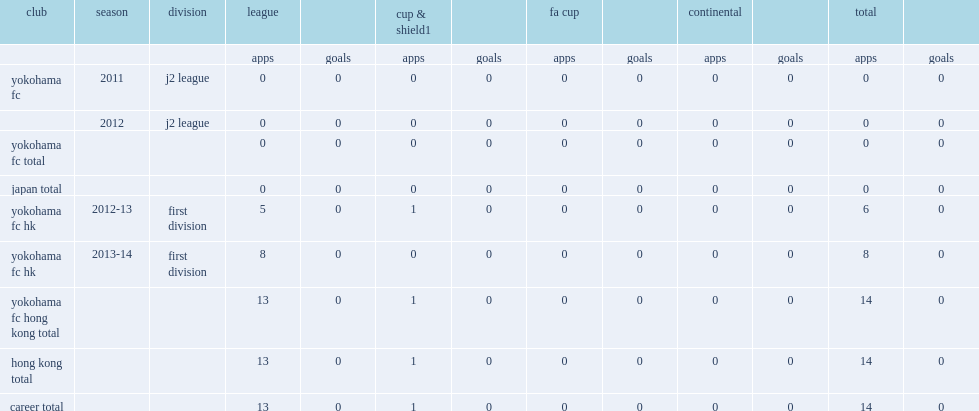Which club did murai play for in 2012-13? Yokohama fc hk. 